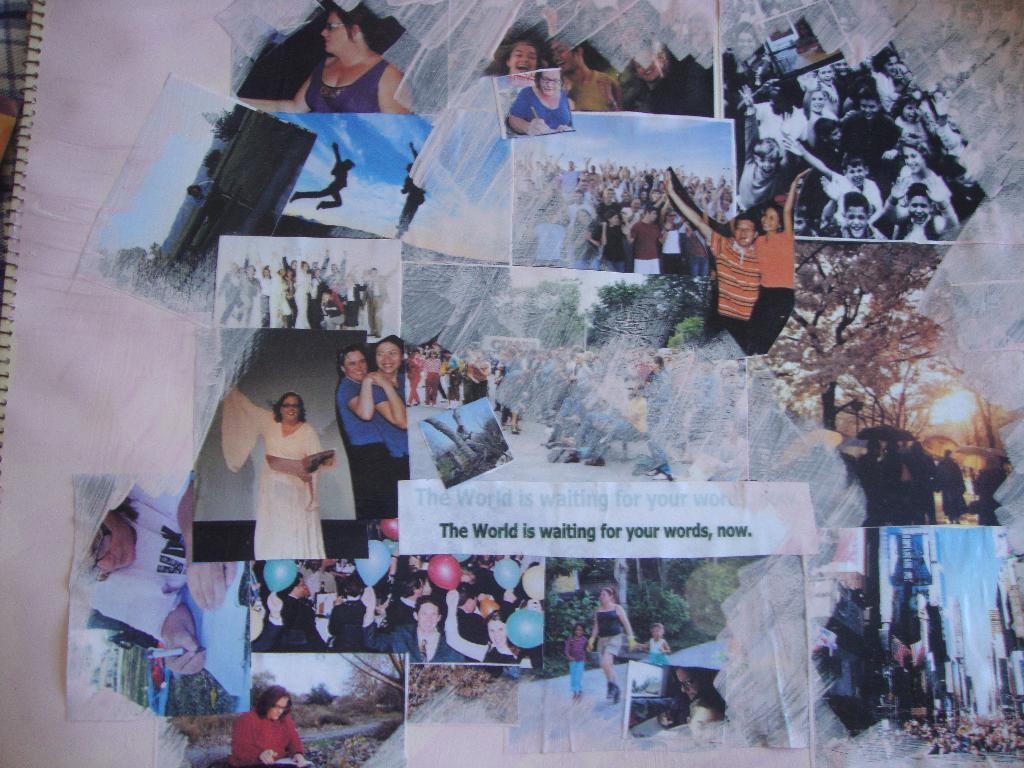<image>
Create a compact narrative representing the image presented. the cover of a notebook decorated in pictures and with a saying "the world is waitng for your words, now" 